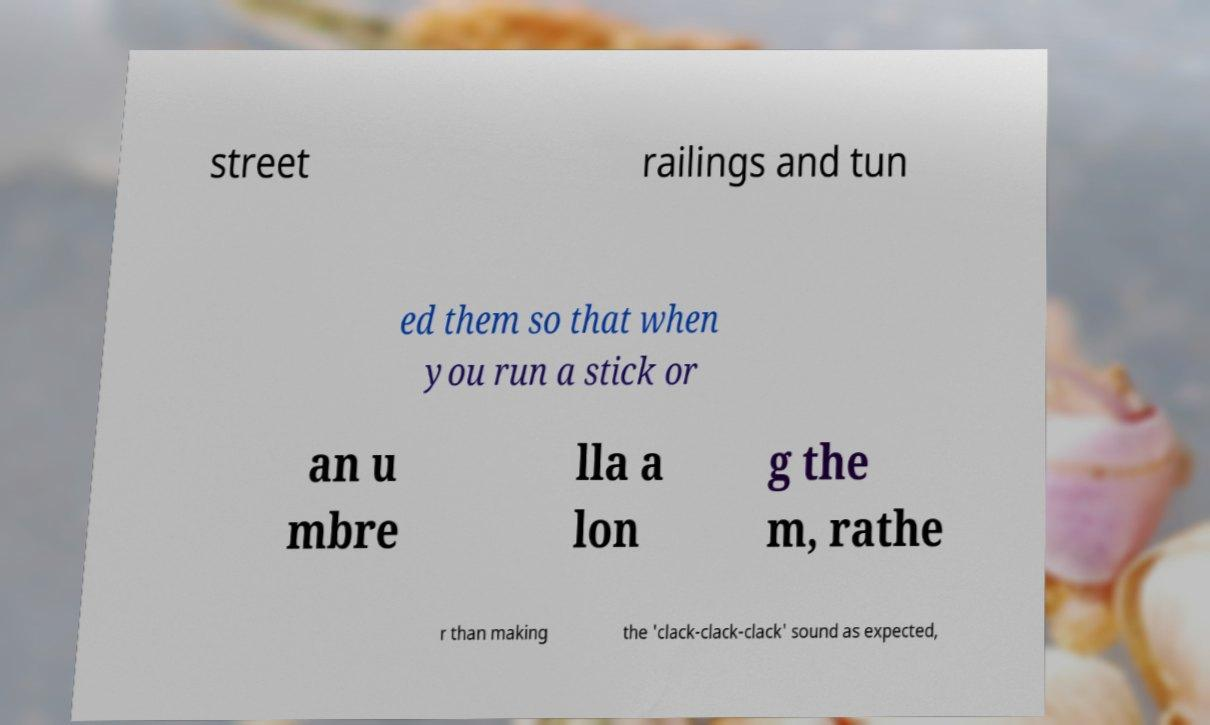For documentation purposes, I need the text within this image transcribed. Could you provide that? street railings and tun ed them so that when you run a stick or an u mbre lla a lon g the m, rathe r than making the 'clack-clack-clack' sound as expected, 